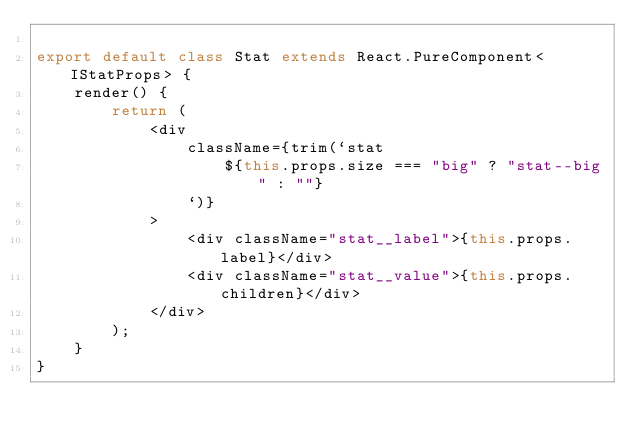Convert code to text. <code><loc_0><loc_0><loc_500><loc_500><_TypeScript_>
export default class Stat extends React.PureComponent<IStatProps> {
    render() {
        return (
            <div
                className={trim(`stat
                    ${this.props.size === "big" ? "stat--big" : ""}
                `)}
            >
                <div className="stat__label">{this.props.label}</div>
                <div className="stat__value">{this.props.children}</div>
            </div>
        );
    }
}
</code> 